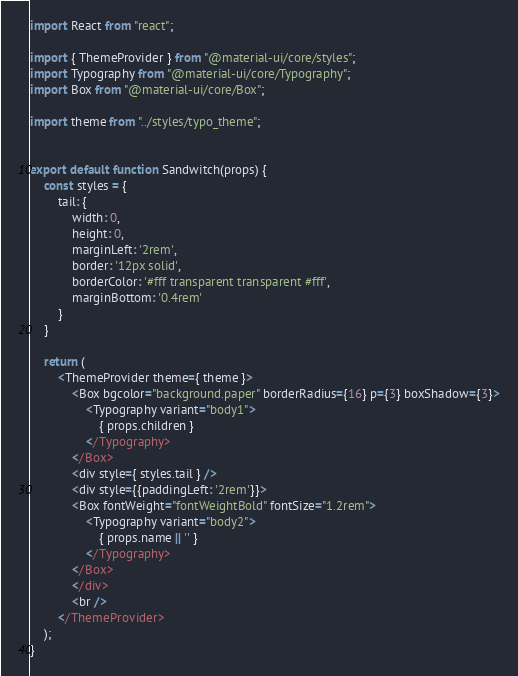<code> <loc_0><loc_0><loc_500><loc_500><_JavaScript_>
import React from "react";

import { ThemeProvider } from "@material-ui/core/styles";
import Typography from "@material-ui/core/Typography";
import Box from "@material-ui/core/Box";

import theme from "../styles/typo_theme";


export default function Sandwitch(props) {
    const styles = {
        tail: {
            width: 0,
            height: 0,
            marginLeft: '2rem',
            border: '12px solid',
            borderColor: '#fff transparent transparent #fff',
            marginBottom: '0.4rem'
        }
    }

    return (
        <ThemeProvider theme={ theme }>
            <Box bgcolor="background.paper" borderRadius={16} p={3} boxShadow={3}>
                <Typography variant="body1">
                    { props.children }
                </Typography>
            </Box>
            <div style={ styles.tail } />
            <div style={{paddingLeft: '2rem'}}>
            <Box fontWeight="fontWeightBold" fontSize="1.2rem">
                <Typography variant="body2">
                    { props.name || '' }
                </Typography>
            </Box>
            </div>
            <br />
        </ThemeProvider>
    );
}</code> 